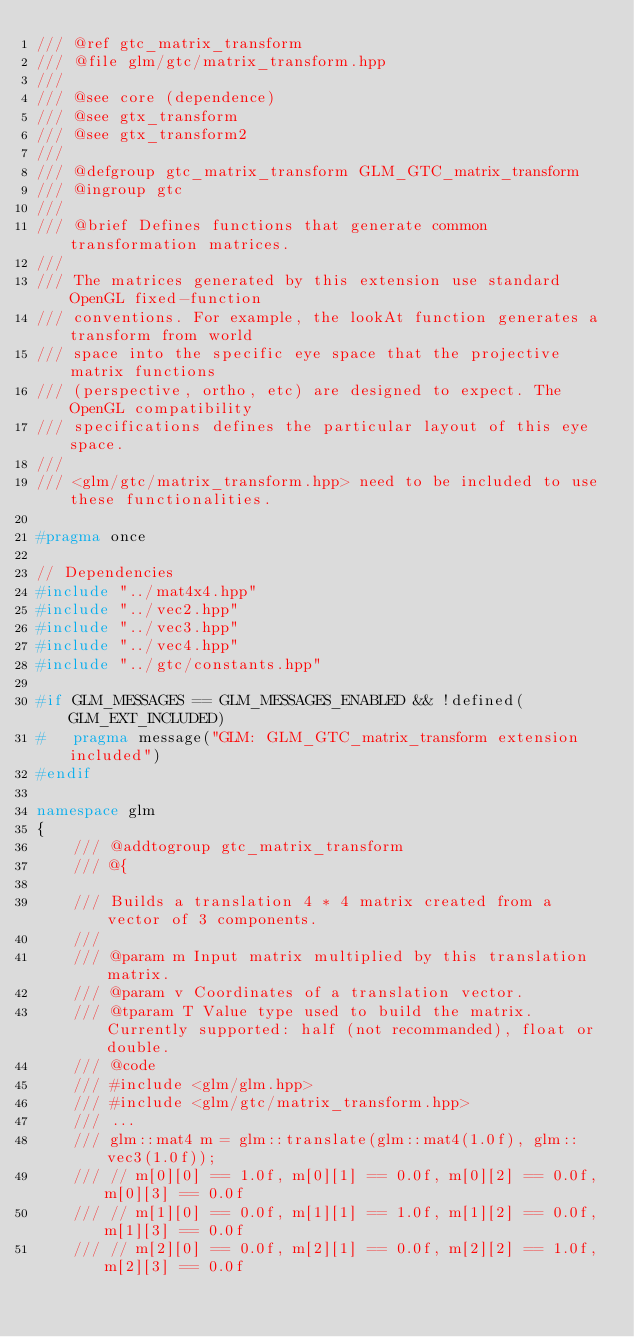Convert code to text. <code><loc_0><loc_0><loc_500><loc_500><_C++_>/// @ref gtc_matrix_transform
/// @file glm/gtc/matrix_transform.hpp
///
/// @see core (dependence)
/// @see gtx_transform
/// @see gtx_transform2
/// 
/// @defgroup gtc_matrix_transform GLM_GTC_matrix_transform
/// @ingroup gtc
///
/// @brief Defines functions that generate common transformation matrices.
///
/// The matrices generated by this extension use standard OpenGL fixed-function
/// conventions. For example, the lookAt function generates a transform from world
/// space into the specific eye space that the projective matrix functions 
/// (perspective, ortho, etc) are designed to expect. The OpenGL compatibility
/// specifications defines the particular layout of this eye space.
///
/// <glm/gtc/matrix_transform.hpp> need to be included to use these functionalities.

#pragma once

// Dependencies
#include "../mat4x4.hpp"
#include "../vec2.hpp"
#include "../vec3.hpp"
#include "../vec4.hpp"
#include "../gtc/constants.hpp"

#if GLM_MESSAGES == GLM_MESSAGES_ENABLED && !defined(GLM_EXT_INCLUDED)
#	pragma message("GLM: GLM_GTC_matrix_transform extension included")
#endif

namespace glm
{
	/// @addtogroup gtc_matrix_transform
	/// @{

	/// Builds a translation 4 * 4 matrix created from a vector of 3 components.
	/// 
	/// @param m Input matrix multiplied by this translation matrix.
	/// @param v Coordinates of a translation vector.
	/// @tparam T Value type used to build the matrix. Currently supported: half (not recommanded), float or double.
	/// @code
	/// #include <glm/glm.hpp>
	/// #include <glm/gtc/matrix_transform.hpp>
	/// ...
	/// glm::mat4 m = glm::translate(glm::mat4(1.0f), glm::vec3(1.0f));
	/// // m[0][0] == 1.0f, m[0][1] == 0.0f, m[0][2] == 0.0f, m[0][3] == 0.0f
	/// // m[1][0] == 0.0f, m[1][1] == 1.0f, m[1][2] == 0.0f, m[1][3] == 0.0f
	/// // m[2][0] == 0.0f, m[2][1] == 0.0f, m[2][2] == 1.0f, m[2][3] == 0.0f</code> 